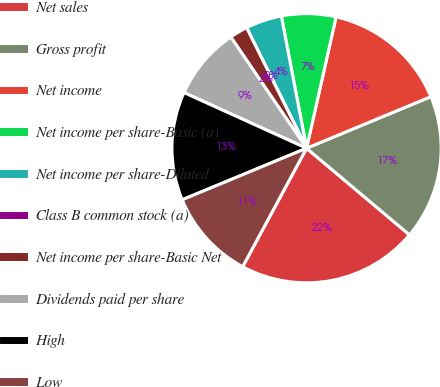Convert chart. <chart><loc_0><loc_0><loc_500><loc_500><pie_chart><fcel>Net sales<fcel>Gross profit<fcel>Net income<fcel>Net income per share-Basic (a)<fcel>Net income per share-Diluted<fcel>Class B common stock (a)<fcel>Net income per share-Basic Net<fcel>Dividends paid per share<fcel>High<fcel>Low<nl><fcel>21.74%<fcel>17.39%<fcel>15.22%<fcel>6.52%<fcel>4.35%<fcel>0.0%<fcel>2.17%<fcel>8.7%<fcel>13.04%<fcel>10.87%<nl></chart> 